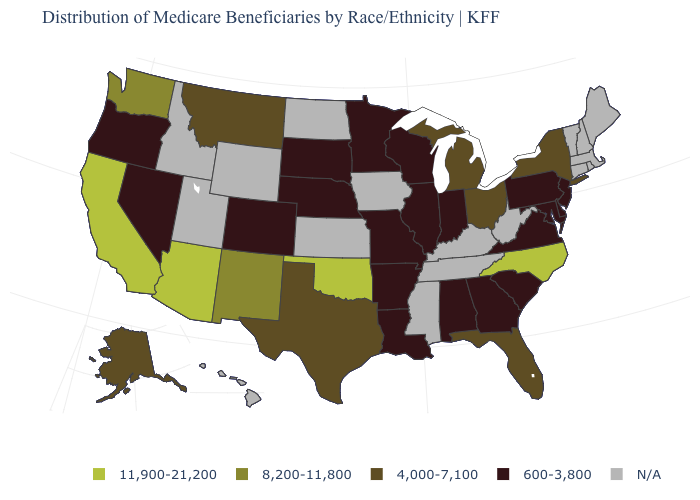What is the value of New Hampshire?
Write a very short answer. N/A. What is the value of Florida?
Short answer required. 4,000-7,100. How many symbols are there in the legend?
Keep it brief. 5. Name the states that have a value in the range 4,000-7,100?
Keep it brief. Alaska, Florida, Michigan, Montana, New York, Ohio, Texas. What is the value of Massachusetts?
Keep it brief. N/A. Name the states that have a value in the range 4,000-7,100?
Concise answer only. Alaska, Florida, Michigan, Montana, New York, Ohio, Texas. Name the states that have a value in the range 600-3,800?
Concise answer only. Alabama, Arkansas, Colorado, Delaware, Georgia, Illinois, Indiana, Louisiana, Maryland, Minnesota, Missouri, Nebraska, Nevada, New Jersey, Oregon, Pennsylvania, South Carolina, South Dakota, Virginia, Wisconsin. What is the highest value in states that border Washington?
Quick response, please. 600-3,800. Name the states that have a value in the range 600-3,800?
Write a very short answer. Alabama, Arkansas, Colorado, Delaware, Georgia, Illinois, Indiana, Louisiana, Maryland, Minnesota, Missouri, Nebraska, Nevada, New Jersey, Oregon, Pennsylvania, South Carolina, South Dakota, Virginia, Wisconsin. Name the states that have a value in the range N/A?
Short answer required. Connecticut, Hawaii, Idaho, Iowa, Kansas, Kentucky, Maine, Massachusetts, Mississippi, New Hampshire, North Dakota, Rhode Island, Tennessee, Utah, Vermont, West Virginia, Wyoming. How many symbols are there in the legend?
Quick response, please. 5. What is the highest value in the USA?
Quick response, please. 11,900-21,200. Name the states that have a value in the range 4,000-7,100?
Quick response, please. Alaska, Florida, Michigan, Montana, New York, Ohio, Texas. Among the states that border Texas , does Louisiana have the highest value?
Keep it brief. No. 